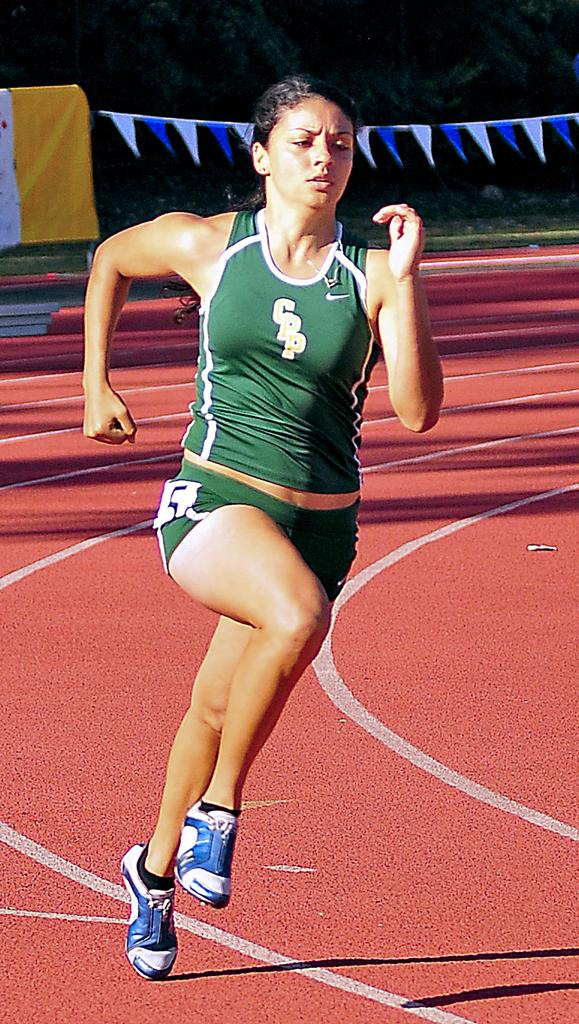<image>
Share a concise interpretation of the image provided. CPP type jersey shirt with a woman that is on track and field with the Nike Logo. 